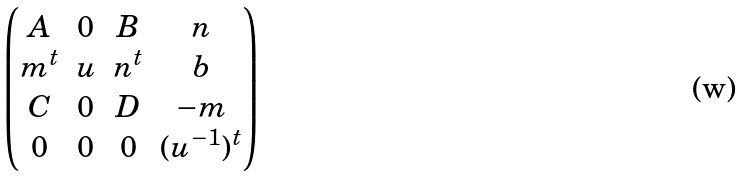<formula> <loc_0><loc_0><loc_500><loc_500>\begin{pmatrix} A & 0 & B & n \\ m ^ { t } & u & n ^ { t } & b \\ C & 0 & D & - m \\ 0 & 0 & 0 & ( u ^ { - 1 } ) ^ { t } \end{pmatrix}</formula> 